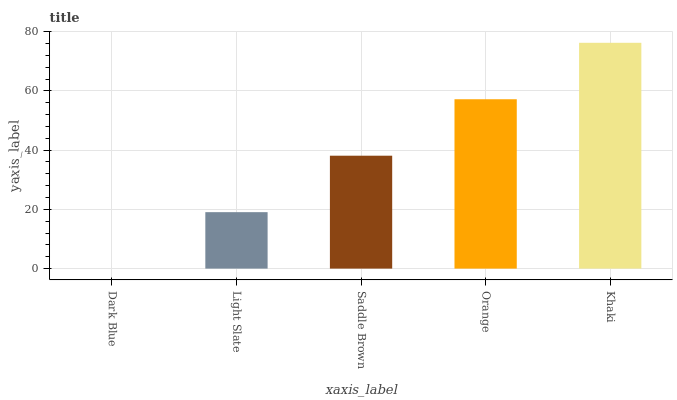Is Dark Blue the minimum?
Answer yes or no. Yes. Is Khaki the maximum?
Answer yes or no. Yes. Is Light Slate the minimum?
Answer yes or no. No. Is Light Slate the maximum?
Answer yes or no. No. Is Light Slate greater than Dark Blue?
Answer yes or no. Yes. Is Dark Blue less than Light Slate?
Answer yes or no. Yes. Is Dark Blue greater than Light Slate?
Answer yes or no. No. Is Light Slate less than Dark Blue?
Answer yes or no. No. Is Saddle Brown the high median?
Answer yes or no. Yes. Is Saddle Brown the low median?
Answer yes or no. Yes. Is Light Slate the high median?
Answer yes or no. No. Is Light Slate the low median?
Answer yes or no. No. 